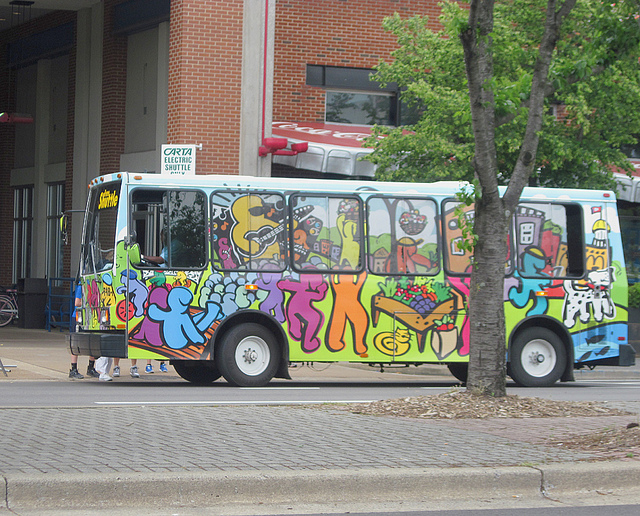Identify the text contained in this image. CARTA SHUTTLE 